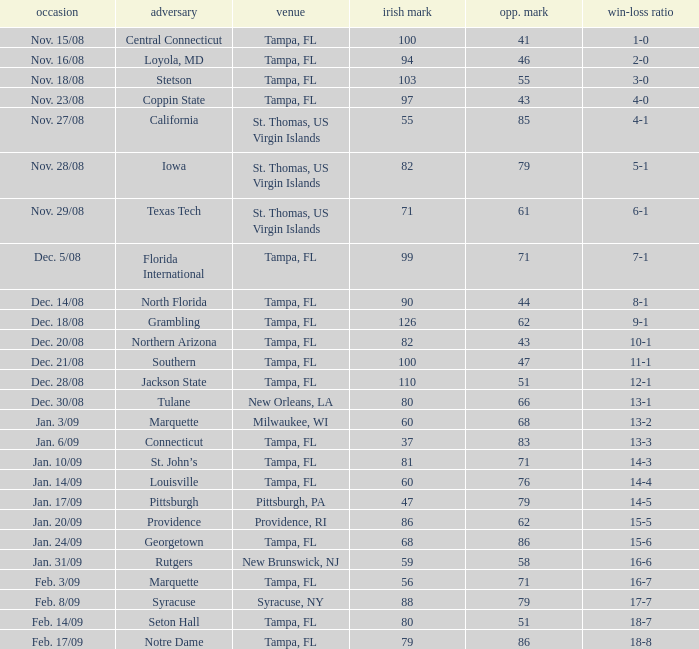What is the record where the opponent is central connecticut? 1-0. 